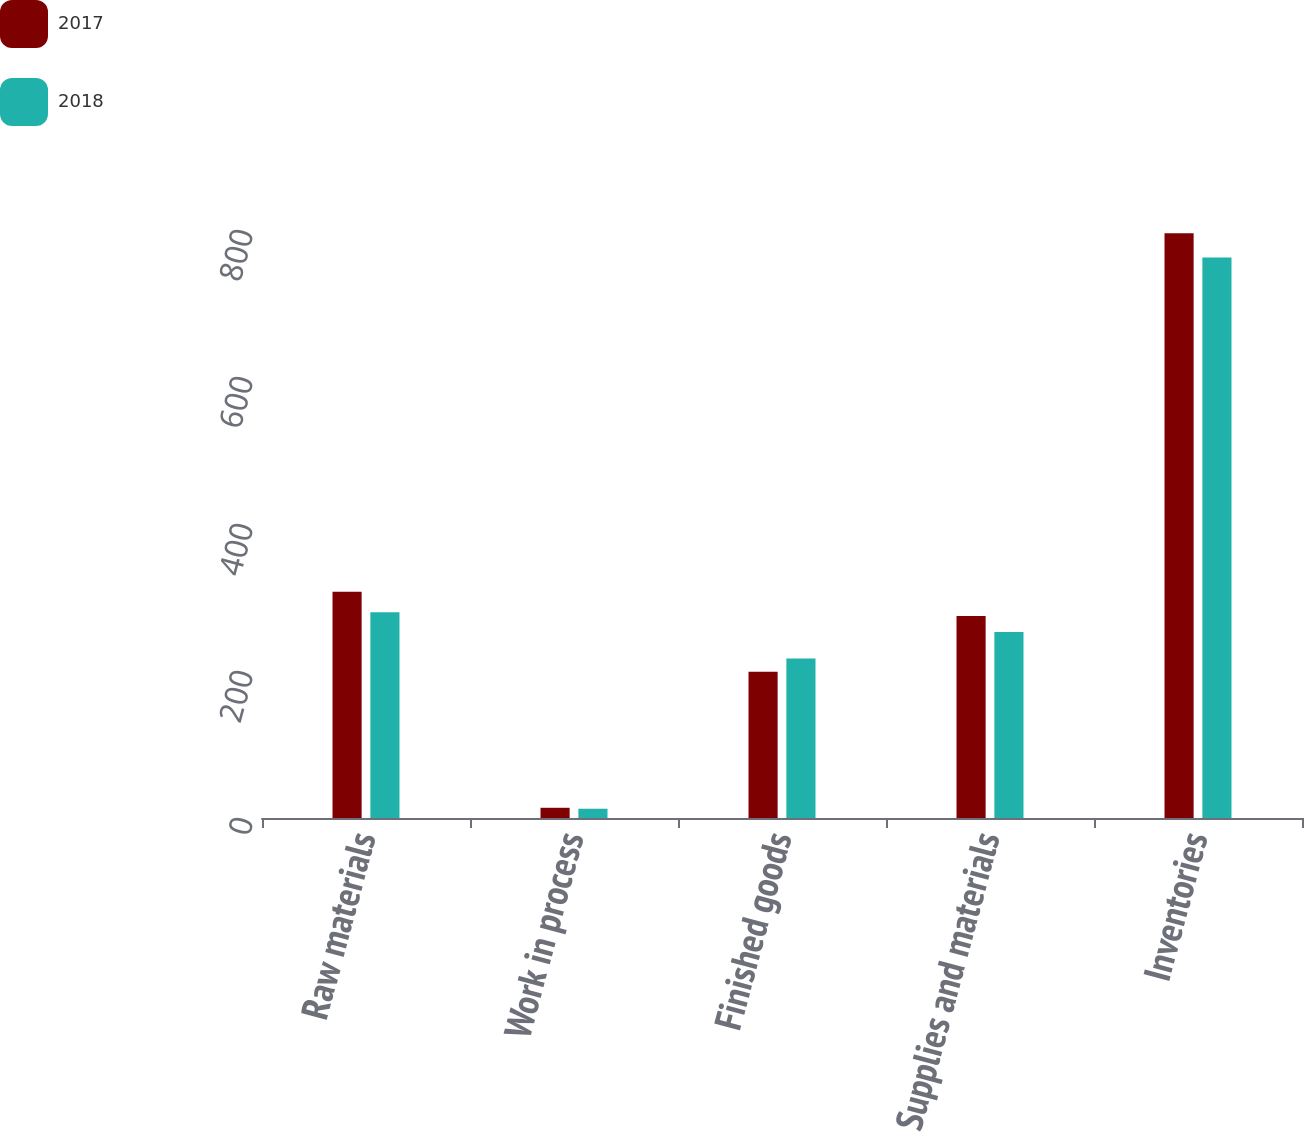<chart> <loc_0><loc_0><loc_500><loc_500><stacked_bar_chart><ecel><fcel>Raw materials<fcel>Work in process<fcel>Finished goods<fcel>Supplies and materials<fcel>Inventories<nl><fcel>2017<fcel>307.8<fcel>13.9<fcel>199<fcel>274.9<fcel>795.6<nl><fcel>2018<fcel>279.8<fcel>12.6<fcel>217<fcel>253.1<fcel>762.5<nl></chart> 